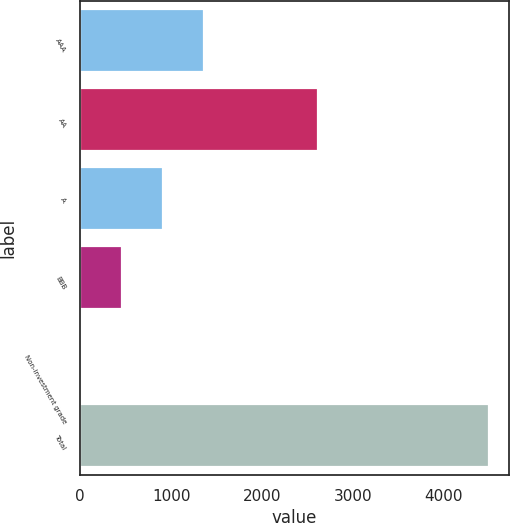Convert chart to OTSL. <chart><loc_0><loc_0><loc_500><loc_500><bar_chart><fcel>AAA<fcel>AA<fcel>A<fcel>BBB<fcel>Non-investment grade<fcel>Total<nl><fcel>1359.4<fcel>2612<fcel>911.6<fcel>463.8<fcel>16<fcel>4494<nl></chart> 